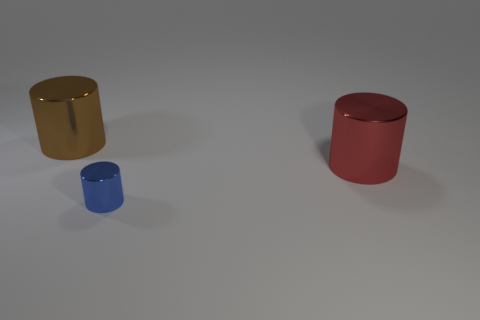Add 2 cylinders. How many objects exist? 5 Add 2 big red metallic things. How many big red metallic things exist? 3 Subtract 1 brown cylinders. How many objects are left? 2 Subtract all gray cubes. Subtract all tiny things. How many objects are left? 2 Add 3 tiny metal cylinders. How many tiny metal cylinders are left? 4 